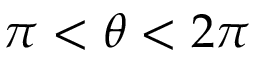<formula> <loc_0><loc_0><loc_500><loc_500>\pi < \theta < 2 \pi</formula> 